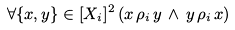Convert formula to latex. <formula><loc_0><loc_0><loc_500><loc_500>\forall \{ x , y \} \in [ X _ { i } ] ^ { 2 } \, ( x \, \rho _ { i } \, y \, \land \, y \, \rho _ { i } \, x )</formula> 